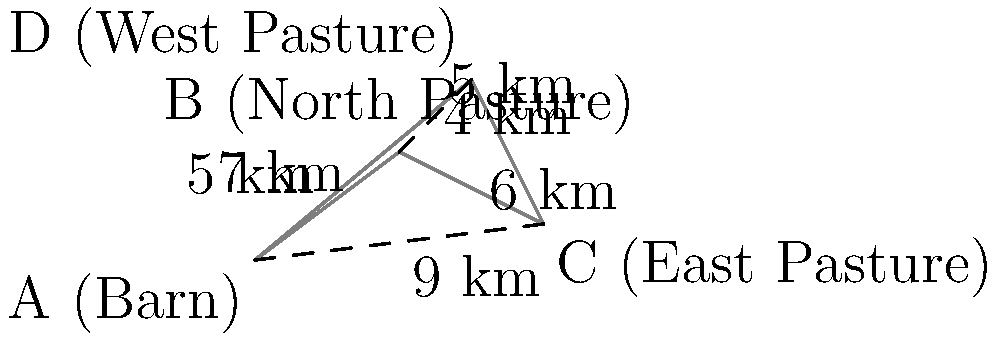As an experienced rancher, you need to plan the most efficient route for herding cattle between multiple grazing areas. The diagram shows the layout of your ranch with distances between locations. The barn (A) is your starting and ending point, and you need to visit all pastures (B, C, and D) exactly once before returning to the barn. What is the shortest possible route in kilometers? To find the shortest route, we need to consider all possible paths that visit each pasture once and return to the barn. Let's analyze this step-by-step:

1) There are 3! = 6 possible orders to visit the three pastures:
   BCD, BCE, CDB, CDE, DCB, DBC

2) For each order, we need to add the distance from A to the first pasture and from the last pasture back to A.

3) Let's calculate the total distance for each possible route:

   A-B-C-D-A: 5 + 6 + 4 + 7 = 22 km
   A-B-D-C-A: 5 + 5 + 4 + 9 = 23 km
   A-C-D-B-A: 9 + 4 + 5 + 5 = 23 km
   A-C-B-D-A: 9 + 6 + 5 + 7 = 27 km
   A-D-C-B-A: 7 + 4 + 6 + 5 = 22 km
   A-D-B-C-A: 7 + 5 + 6 + 9 = 27 km

4) From these calculations, we can see that there are two routes with the shortest distance of 22 km:
   A-B-C-D-A and A-D-C-B-A

Therefore, the shortest possible route is 22 km.
Answer: 22 km 